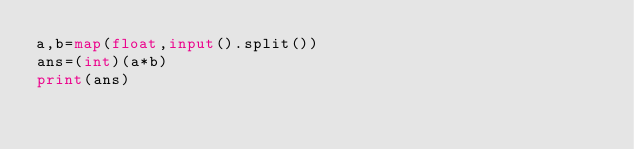Convert code to text. <code><loc_0><loc_0><loc_500><loc_500><_Python_>a,b=map(float,input().split())
ans=(int)(a*b)
print(ans)</code> 